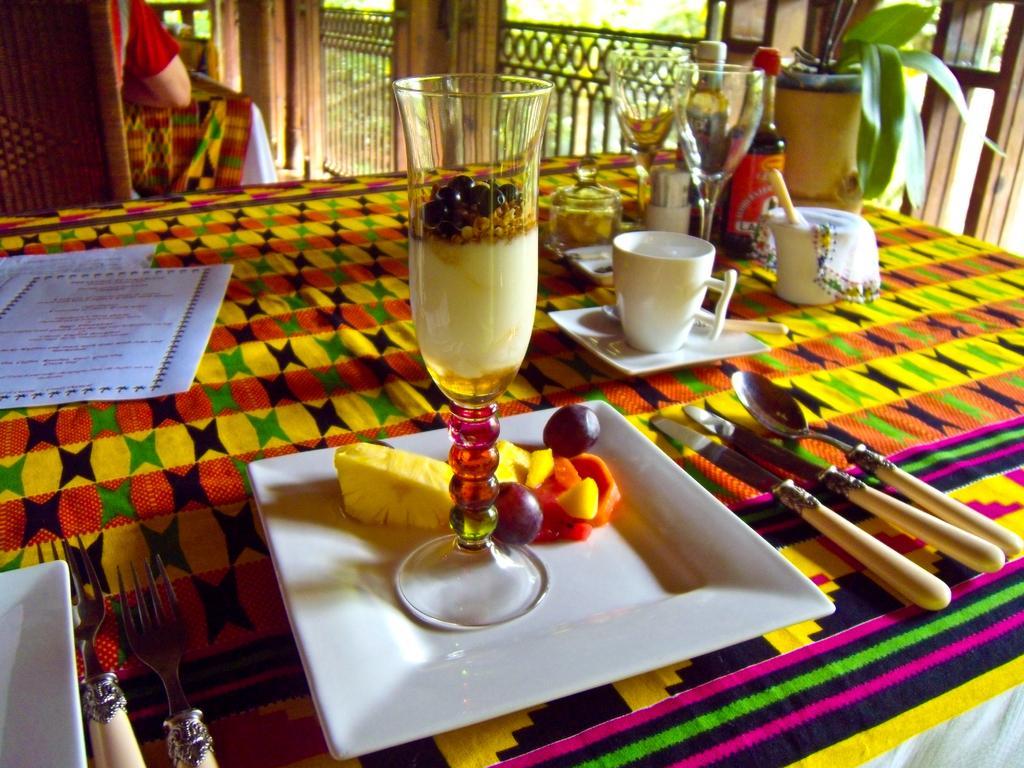Please provide a concise description of this image. On this table there is a glass, papers, cups, bottles and plant. In this plate and glass there is a food. Beside this place there is a knife and spoon. Far this person is sitting on a chair. 